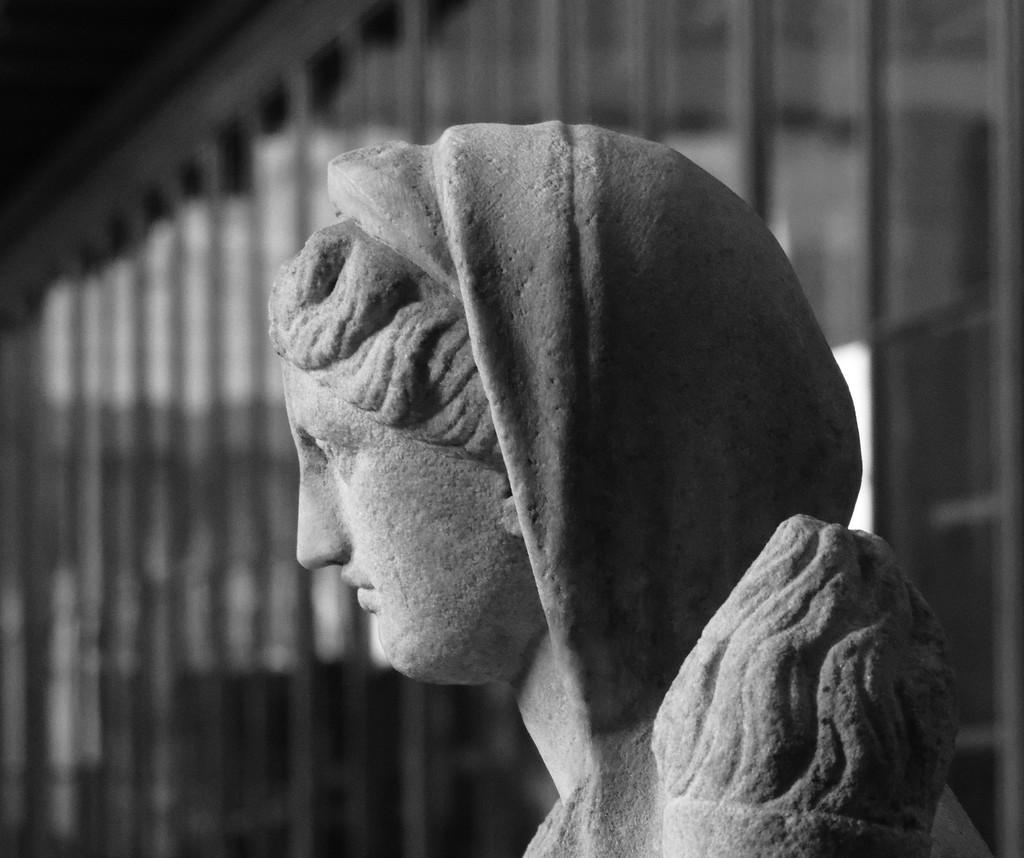What is the main subject of the image? There is a grey color sculpture in the image. Can you describe the sculpture? The sculpture is of a woman. How would you characterize the image's background? The image is blurry in the background. What type of plant can be seen growing out of the woman's head in the image? There is no plant growing out of the woman's head in the image; it is a sculpture of a woman without any plants. 